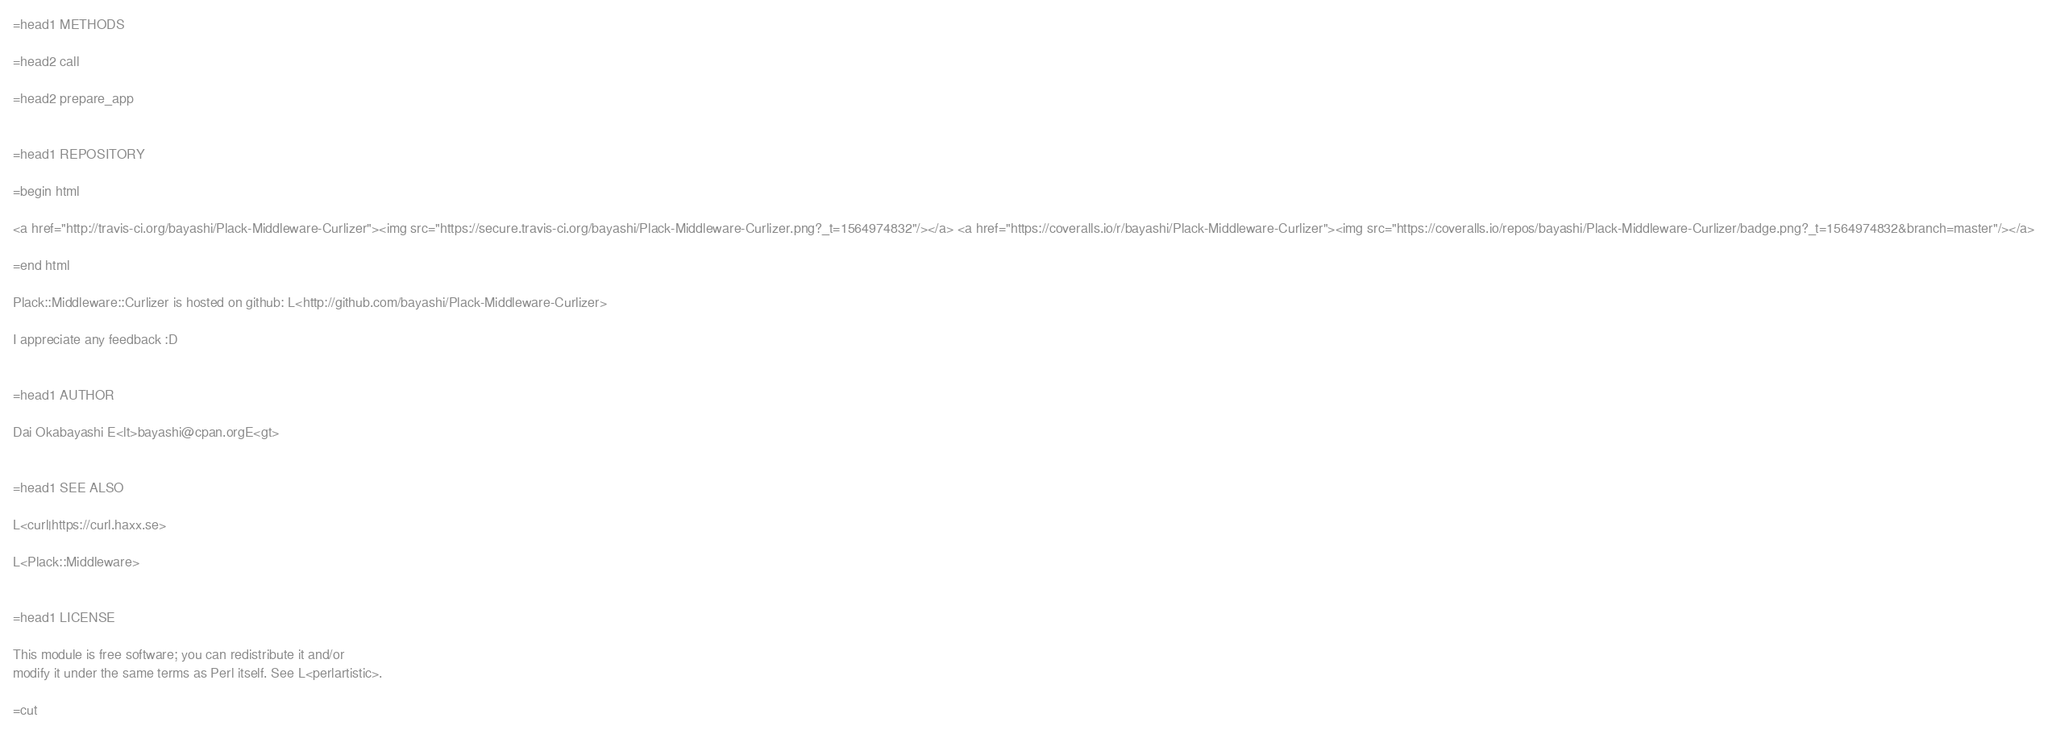<code> <loc_0><loc_0><loc_500><loc_500><_Perl_>

=head1 METHODS

=head2 call

=head2 prepare_app


=head1 REPOSITORY

=begin html

<a href="http://travis-ci.org/bayashi/Plack-Middleware-Curlizer"><img src="https://secure.travis-ci.org/bayashi/Plack-Middleware-Curlizer.png?_t=1564974832"/></a> <a href="https://coveralls.io/r/bayashi/Plack-Middleware-Curlizer"><img src="https://coveralls.io/repos/bayashi/Plack-Middleware-Curlizer/badge.png?_t=1564974832&branch=master"/></a>

=end html

Plack::Middleware::Curlizer is hosted on github: L<http://github.com/bayashi/Plack-Middleware-Curlizer>

I appreciate any feedback :D


=head1 AUTHOR

Dai Okabayashi E<lt>bayashi@cpan.orgE<gt>


=head1 SEE ALSO

L<curl|https://curl.haxx.se>

L<Plack::Middleware>


=head1 LICENSE

This module is free software; you can redistribute it and/or
modify it under the same terms as Perl itself. See L<perlartistic>.

=cut
</code> 